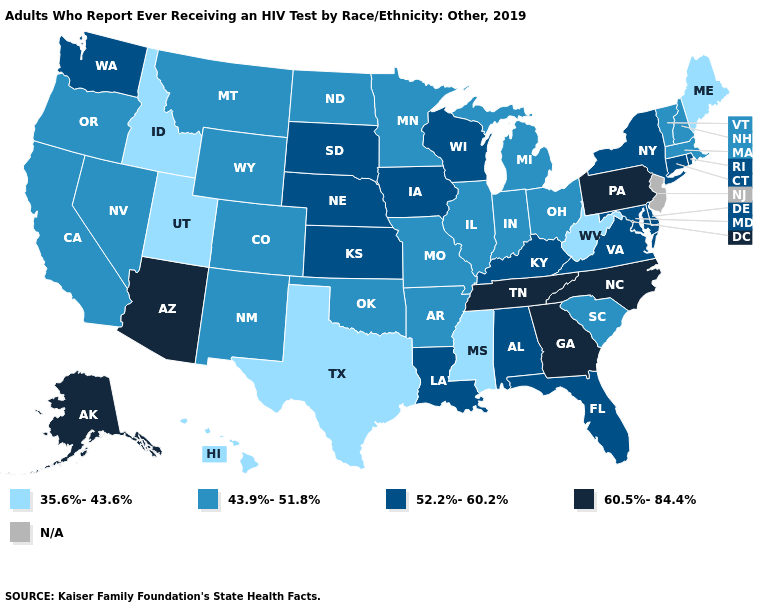Is the legend a continuous bar?
Answer briefly. No. Name the states that have a value in the range 60.5%-84.4%?
Concise answer only. Alaska, Arizona, Georgia, North Carolina, Pennsylvania, Tennessee. Name the states that have a value in the range 35.6%-43.6%?
Write a very short answer. Hawaii, Idaho, Maine, Mississippi, Texas, Utah, West Virginia. What is the value of Michigan?
Be succinct. 43.9%-51.8%. What is the value of Hawaii?
Keep it brief. 35.6%-43.6%. What is the value of Nevada?
Write a very short answer. 43.9%-51.8%. How many symbols are there in the legend?
Quick response, please. 5. Name the states that have a value in the range 60.5%-84.4%?
Write a very short answer. Alaska, Arizona, Georgia, North Carolina, Pennsylvania, Tennessee. Which states have the lowest value in the Northeast?
Write a very short answer. Maine. Which states have the lowest value in the USA?
Be succinct. Hawaii, Idaho, Maine, Mississippi, Texas, Utah, West Virginia. What is the value of New Hampshire?
Keep it brief. 43.9%-51.8%. Name the states that have a value in the range N/A?
Quick response, please. New Jersey. What is the value of Delaware?
Concise answer only. 52.2%-60.2%. Does Pennsylvania have the highest value in the Northeast?
Quick response, please. Yes. What is the value of Oregon?
Quick response, please. 43.9%-51.8%. 